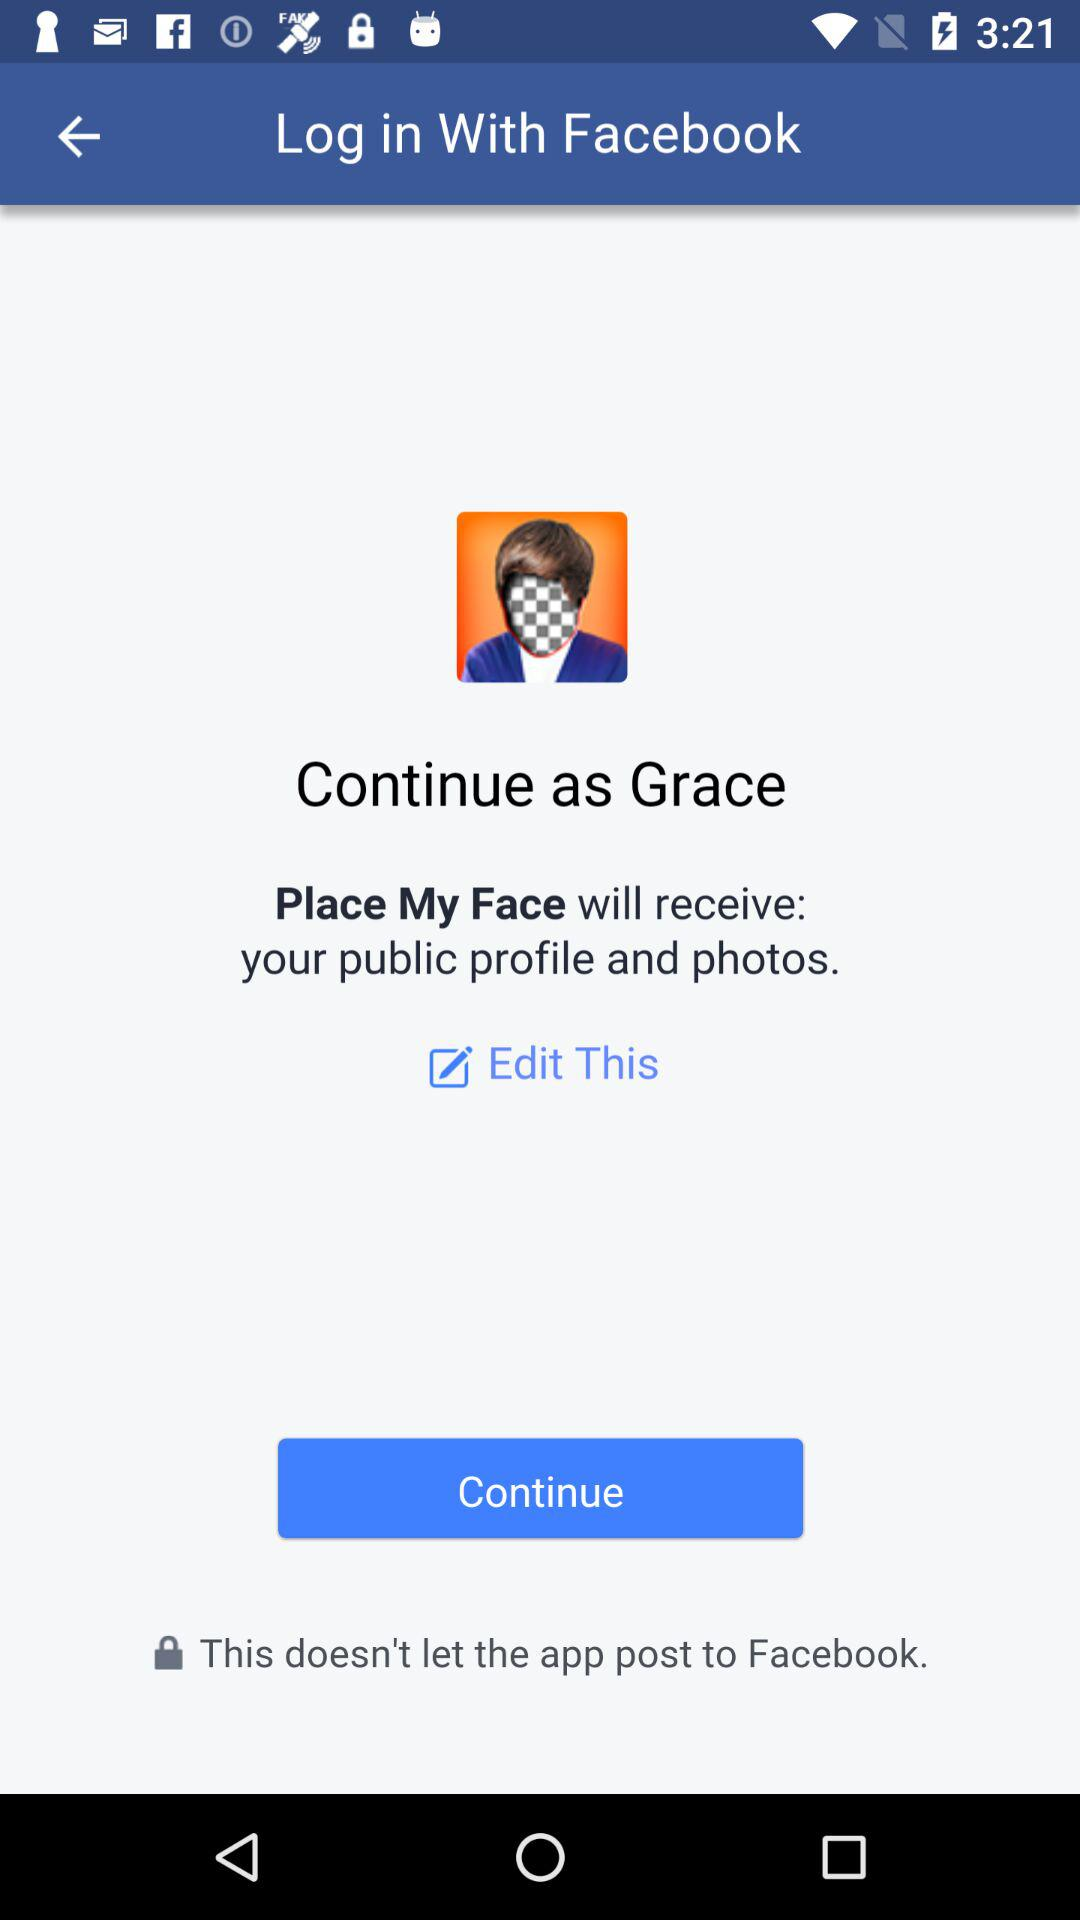What application is asking for permission? The application asking for permission is "Place My Face". 